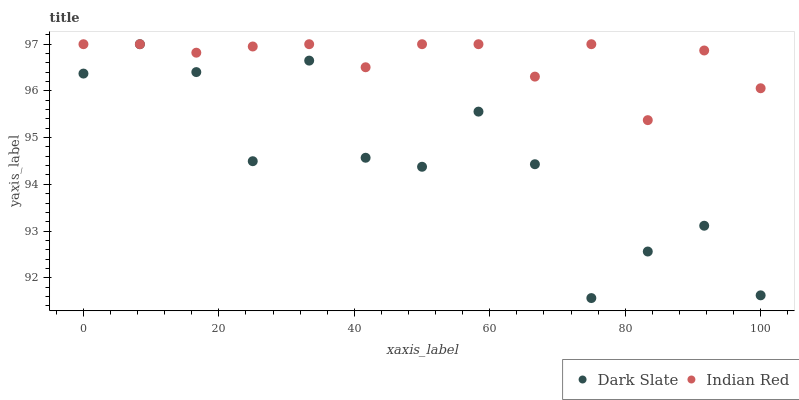Does Dark Slate have the minimum area under the curve?
Answer yes or no. Yes. Does Indian Red have the maximum area under the curve?
Answer yes or no. Yes. Does Indian Red have the minimum area under the curve?
Answer yes or no. No. Is Indian Red the smoothest?
Answer yes or no. Yes. Is Dark Slate the roughest?
Answer yes or no. Yes. Is Indian Red the roughest?
Answer yes or no. No. Does Dark Slate have the lowest value?
Answer yes or no. Yes. Does Indian Red have the lowest value?
Answer yes or no. No. Does Indian Red have the highest value?
Answer yes or no. Yes. Does Dark Slate intersect Indian Red?
Answer yes or no. Yes. Is Dark Slate less than Indian Red?
Answer yes or no. No. Is Dark Slate greater than Indian Red?
Answer yes or no. No. 